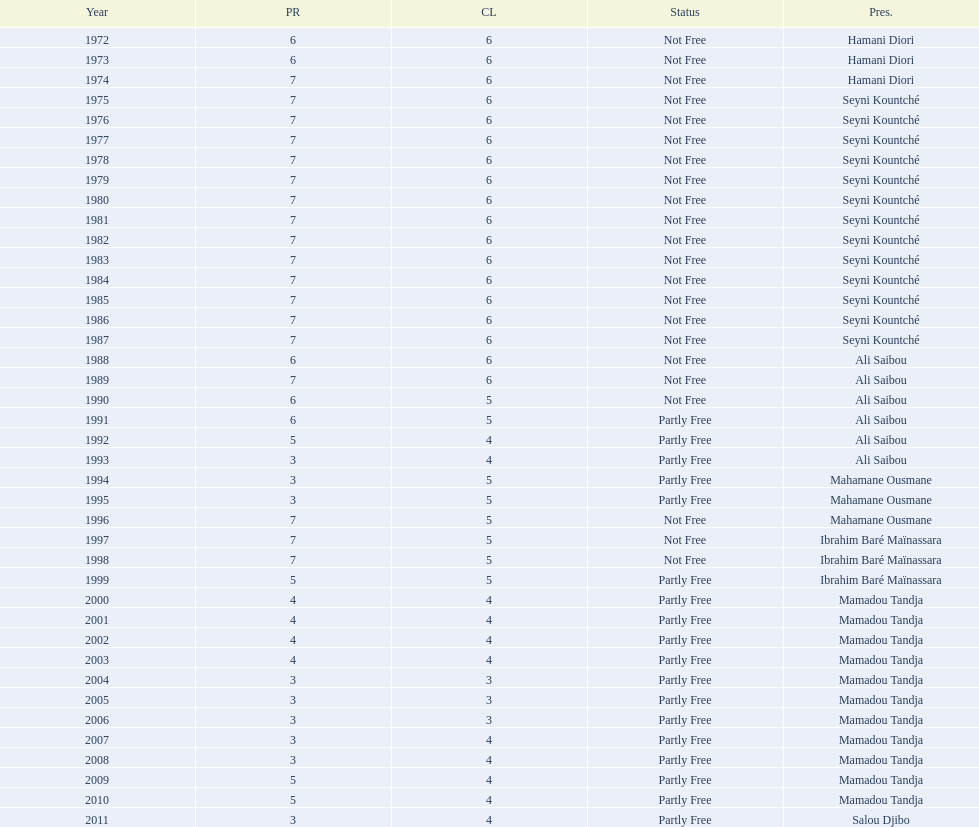How long did it take for civil liberties to decrease below 6? 18 years. Can you parse all the data within this table? {'header': ['Year', 'PR', 'CL', 'Status', 'Pres.'], 'rows': [['1972', '6', '6', 'Not Free', 'Hamani Diori'], ['1973', '6', '6', 'Not Free', 'Hamani Diori'], ['1974', '7', '6', 'Not Free', 'Hamani Diori'], ['1975', '7', '6', 'Not Free', 'Seyni Kountché'], ['1976', '7', '6', 'Not Free', 'Seyni Kountché'], ['1977', '7', '6', 'Not Free', 'Seyni Kountché'], ['1978', '7', '6', 'Not Free', 'Seyni Kountché'], ['1979', '7', '6', 'Not Free', 'Seyni Kountché'], ['1980', '7', '6', 'Not Free', 'Seyni Kountché'], ['1981', '7', '6', 'Not Free', 'Seyni Kountché'], ['1982', '7', '6', 'Not Free', 'Seyni Kountché'], ['1983', '7', '6', 'Not Free', 'Seyni Kountché'], ['1984', '7', '6', 'Not Free', 'Seyni Kountché'], ['1985', '7', '6', 'Not Free', 'Seyni Kountché'], ['1986', '7', '6', 'Not Free', 'Seyni Kountché'], ['1987', '7', '6', 'Not Free', 'Seyni Kountché'], ['1988', '6', '6', 'Not Free', 'Ali Saibou'], ['1989', '7', '6', 'Not Free', 'Ali Saibou'], ['1990', '6', '5', 'Not Free', 'Ali Saibou'], ['1991', '6', '5', 'Partly Free', 'Ali Saibou'], ['1992', '5', '4', 'Partly Free', 'Ali Saibou'], ['1993', '3', '4', 'Partly Free', 'Ali Saibou'], ['1994', '3', '5', 'Partly Free', 'Mahamane Ousmane'], ['1995', '3', '5', 'Partly Free', 'Mahamane Ousmane'], ['1996', '7', '5', 'Not Free', 'Mahamane Ousmane'], ['1997', '7', '5', 'Not Free', 'Ibrahim Baré Maïnassara'], ['1998', '7', '5', 'Not Free', 'Ibrahim Baré Maïnassara'], ['1999', '5', '5', 'Partly Free', 'Ibrahim Baré Maïnassara'], ['2000', '4', '4', 'Partly Free', 'Mamadou Tandja'], ['2001', '4', '4', 'Partly Free', 'Mamadou Tandja'], ['2002', '4', '4', 'Partly Free', 'Mamadou Tandja'], ['2003', '4', '4', 'Partly Free', 'Mamadou Tandja'], ['2004', '3', '3', 'Partly Free', 'Mamadou Tandja'], ['2005', '3', '3', 'Partly Free', 'Mamadou Tandja'], ['2006', '3', '3', 'Partly Free', 'Mamadou Tandja'], ['2007', '3', '4', 'Partly Free', 'Mamadou Tandja'], ['2008', '3', '4', 'Partly Free', 'Mamadou Tandja'], ['2009', '5', '4', 'Partly Free', 'Mamadou Tandja'], ['2010', '5', '4', 'Partly Free', 'Mamadou Tandja'], ['2011', '3', '4', 'Partly Free', 'Salou Djibo']]} 